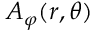Convert formula to latex. <formula><loc_0><loc_0><loc_500><loc_500>A _ { \varphi } ( r , \theta )</formula> 